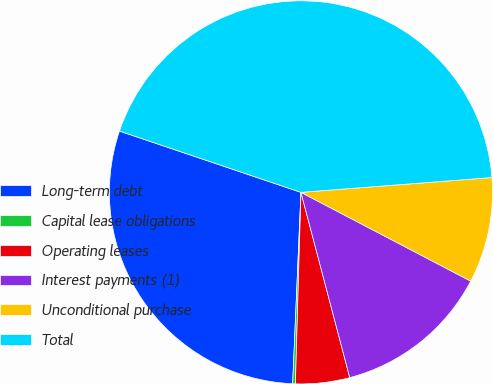<chart> <loc_0><loc_0><loc_500><loc_500><pie_chart><fcel>Long-term debt<fcel>Capital lease obligations<fcel>Operating leases<fcel>Interest payments (1)<fcel>Unconditional purchase<fcel>Total<nl><fcel>29.49%<fcel>0.23%<fcel>4.56%<fcel>13.23%<fcel>8.9%<fcel>43.58%<nl></chart> 